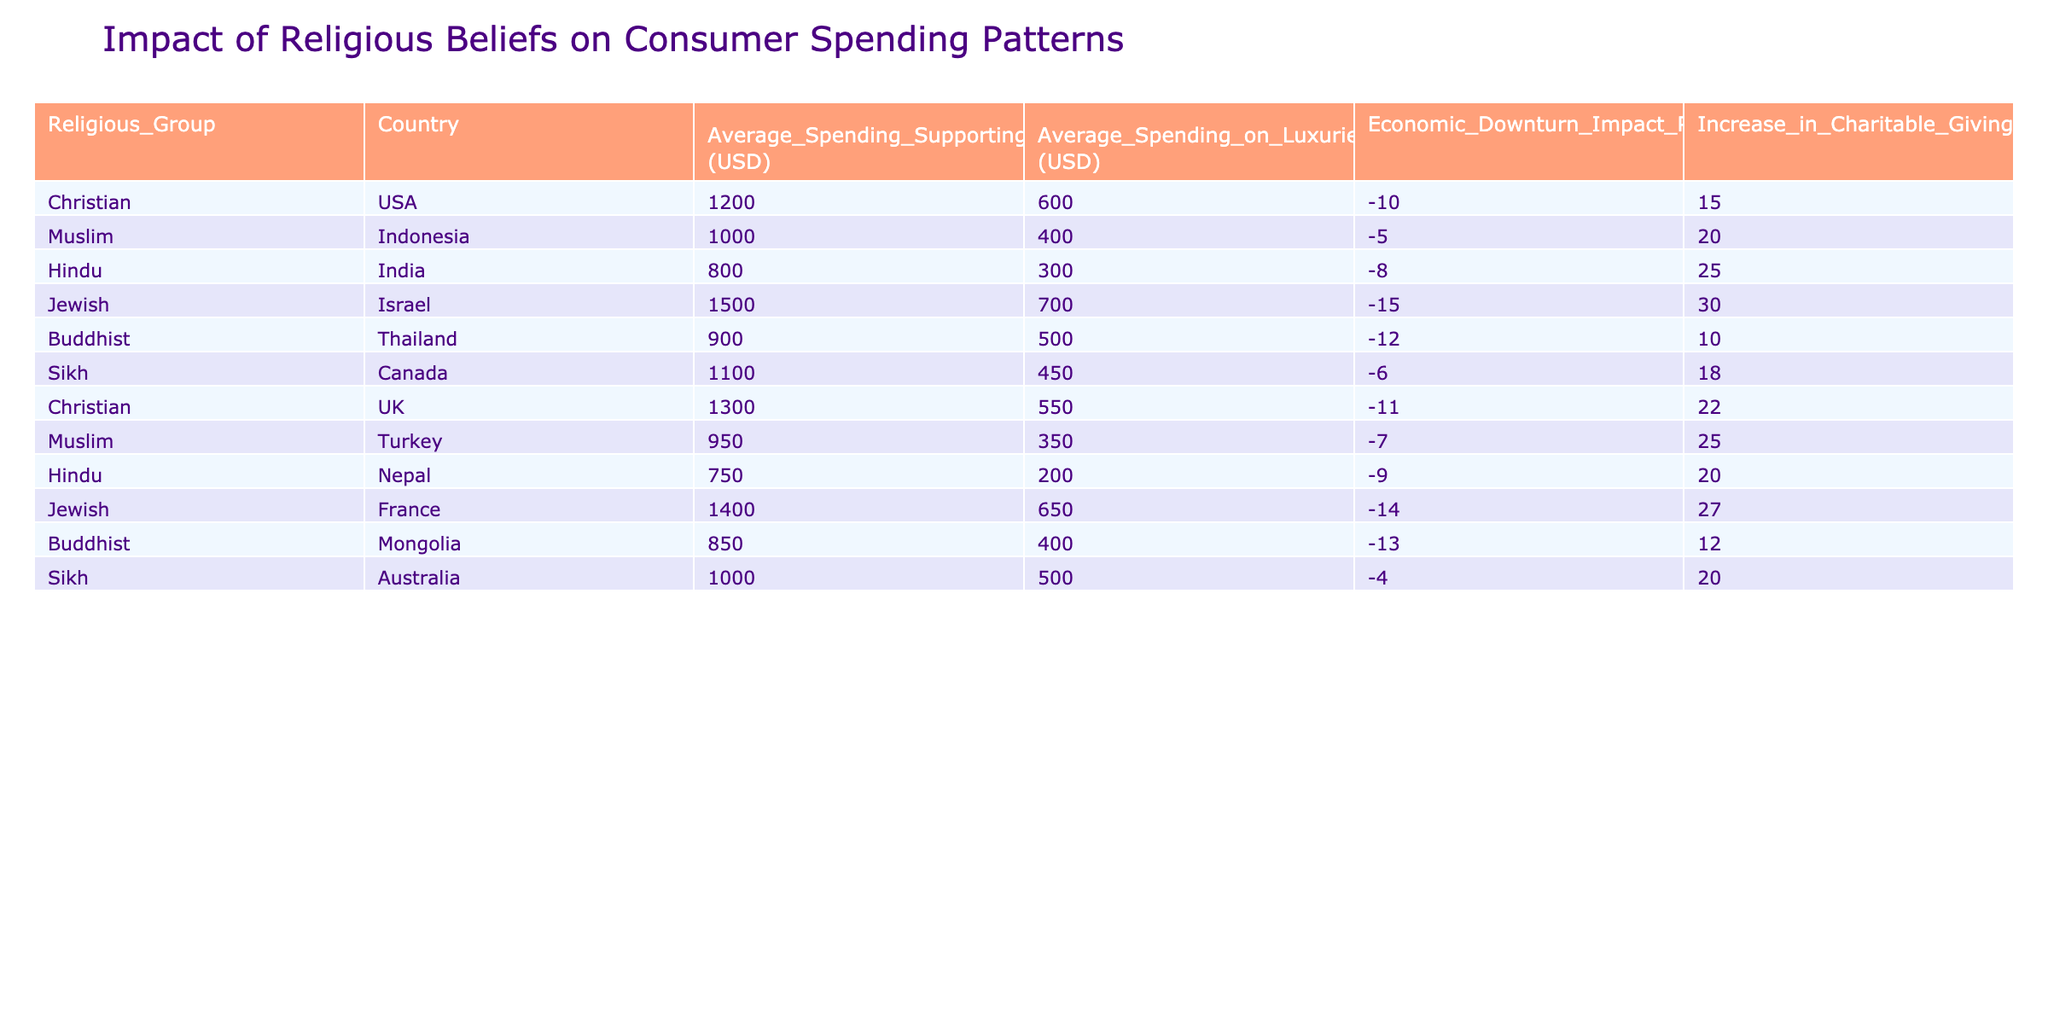What is the average spending on luxuries for the Christian group in the USA? The table shows the average spending on luxuries for the Christian group in the USA as 600 USD.
Answer: 600 USD Which religious group has the highest average spending on essentials? The table indicates that the Jewish group in Israel has the highest average spending on essentials at 1500 USD.
Answer: 1500 USD What is the difference in average spending on essentials between Muslims in Indonesia and Hindus in India? The average spending on essentials for Muslims in Indonesia is 1000 USD, while for Hindus in India, it is 800 USD. The difference is 1000 - 800 = 200 USD.
Answer: 200 USD Did Buddhists in Thailand increase their charitable giving during the economic downturn? According to the table, Buddhists in Thailand increased their charitable giving by 10 percent, indicating that they did increase their charitable giving during the downturn.
Answer: Yes Which religious group experienced the least impact percentage during the economic downturn? The table shows that the Sikh group in Canada experienced the least impact percentage at -4 in the economic downturn.
Answer: -4 